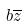Convert formula to latex. <formula><loc_0><loc_0><loc_500><loc_500>b \overline { z }</formula> 